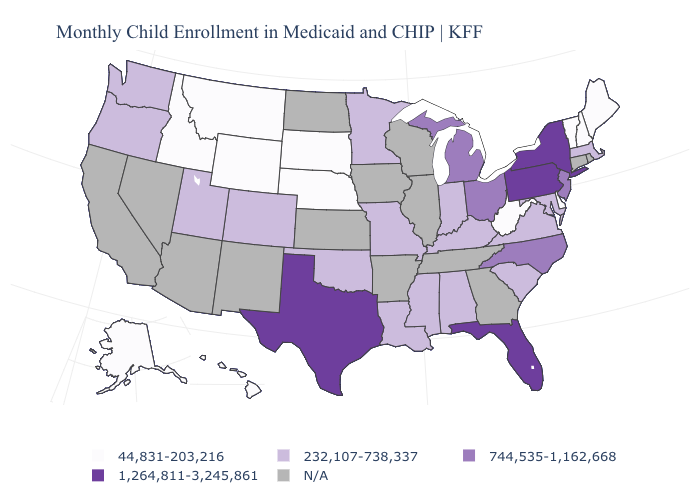Name the states that have a value in the range N/A?
Give a very brief answer. Arizona, Arkansas, California, Connecticut, Georgia, Illinois, Iowa, Kansas, Nevada, New Mexico, North Dakota, Rhode Island, Tennessee, Wisconsin. What is the value of Maryland?
Give a very brief answer. 232,107-738,337. Name the states that have a value in the range 232,107-738,337?
Be succinct. Alabama, Colorado, Indiana, Kentucky, Louisiana, Maryland, Massachusetts, Minnesota, Mississippi, Missouri, Oklahoma, Oregon, South Carolina, Utah, Virginia, Washington. What is the highest value in the USA?
Short answer required. 1,264,811-3,245,861. Name the states that have a value in the range 744,535-1,162,668?
Give a very brief answer. Michigan, New Jersey, North Carolina, Ohio. Name the states that have a value in the range 1,264,811-3,245,861?
Give a very brief answer. Florida, New York, Pennsylvania, Texas. Among the states that border Wyoming , which have the lowest value?
Quick response, please. Idaho, Montana, Nebraska, South Dakota. Name the states that have a value in the range 44,831-203,216?
Be succinct. Alaska, Delaware, Hawaii, Idaho, Maine, Montana, Nebraska, New Hampshire, South Dakota, Vermont, West Virginia, Wyoming. Name the states that have a value in the range N/A?
Short answer required. Arizona, Arkansas, California, Connecticut, Georgia, Illinois, Iowa, Kansas, Nevada, New Mexico, North Dakota, Rhode Island, Tennessee, Wisconsin. What is the value of Arkansas?
Be succinct. N/A. What is the highest value in the MidWest ?
Concise answer only. 744,535-1,162,668. Name the states that have a value in the range 232,107-738,337?
Concise answer only. Alabama, Colorado, Indiana, Kentucky, Louisiana, Maryland, Massachusetts, Minnesota, Mississippi, Missouri, Oklahoma, Oregon, South Carolina, Utah, Virginia, Washington. Among the states that border Virginia , does West Virginia have the lowest value?
Write a very short answer. Yes. Does Nebraska have the highest value in the USA?
Give a very brief answer. No. 